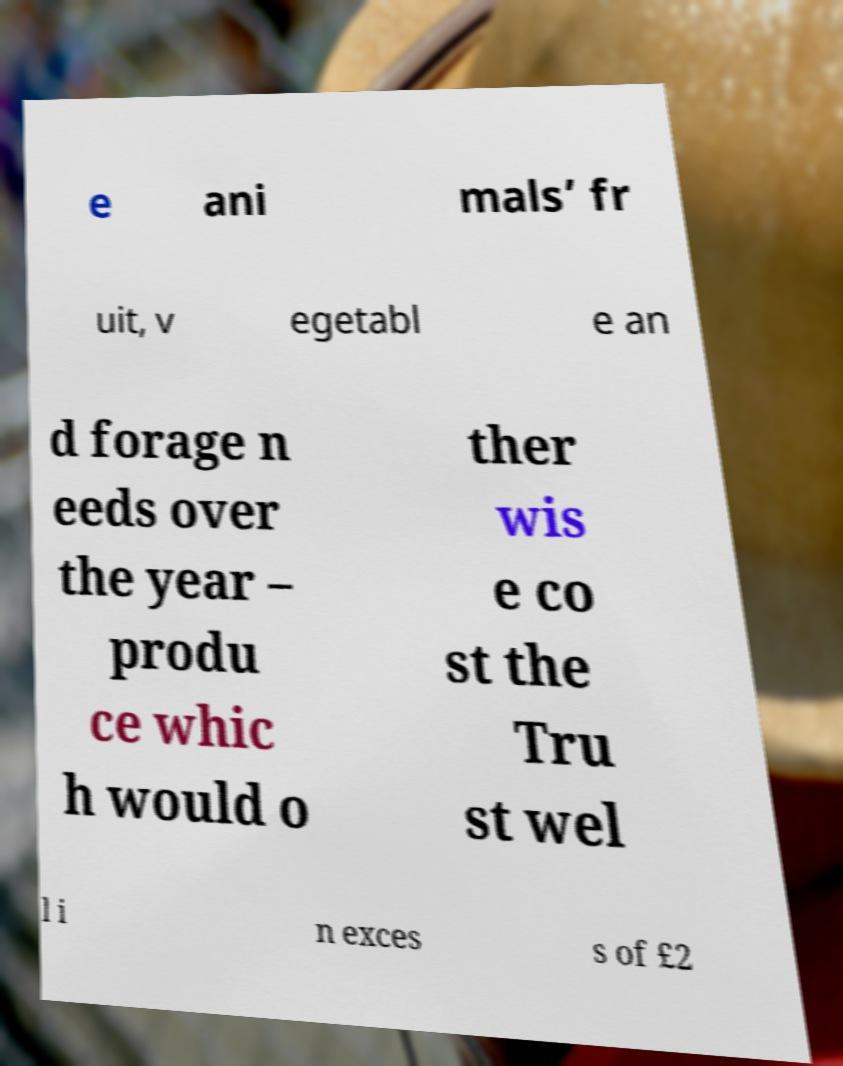There's text embedded in this image that I need extracted. Can you transcribe it verbatim? e ani mals’ fr uit, v egetabl e an d forage n eeds over the year – produ ce whic h would o ther wis e co st the Tru st wel l i n exces s of £2 